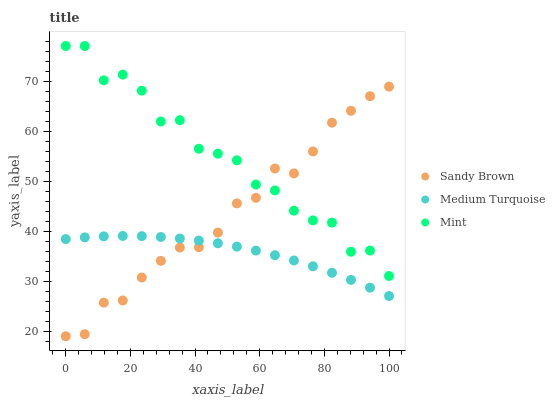Does Medium Turquoise have the minimum area under the curve?
Answer yes or no. Yes. Does Mint have the maximum area under the curve?
Answer yes or no. Yes. Does Sandy Brown have the minimum area under the curve?
Answer yes or no. No. Does Sandy Brown have the maximum area under the curve?
Answer yes or no. No. Is Medium Turquoise the smoothest?
Answer yes or no. Yes. Is Mint the roughest?
Answer yes or no. Yes. Is Sandy Brown the smoothest?
Answer yes or no. No. Is Sandy Brown the roughest?
Answer yes or no. No. Does Sandy Brown have the lowest value?
Answer yes or no. Yes. Does Medium Turquoise have the lowest value?
Answer yes or no. No. Does Mint have the highest value?
Answer yes or no. Yes. Does Sandy Brown have the highest value?
Answer yes or no. No. Is Medium Turquoise less than Mint?
Answer yes or no. Yes. Is Mint greater than Medium Turquoise?
Answer yes or no. Yes. Does Sandy Brown intersect Mint?
Answer yes or no. Yes. Is Sandy Brown less than Mint?
Answer yes or no. No. Is Sandy Brown greater than Mint?
Answer yes or no. No. Does Medium Turquoise intersect Mint?
Answer yes or no. No. 